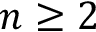Convert formula to latex. <formula><loc_0><loc_0><loc_500><loc_500>n \geq 2</formula> 